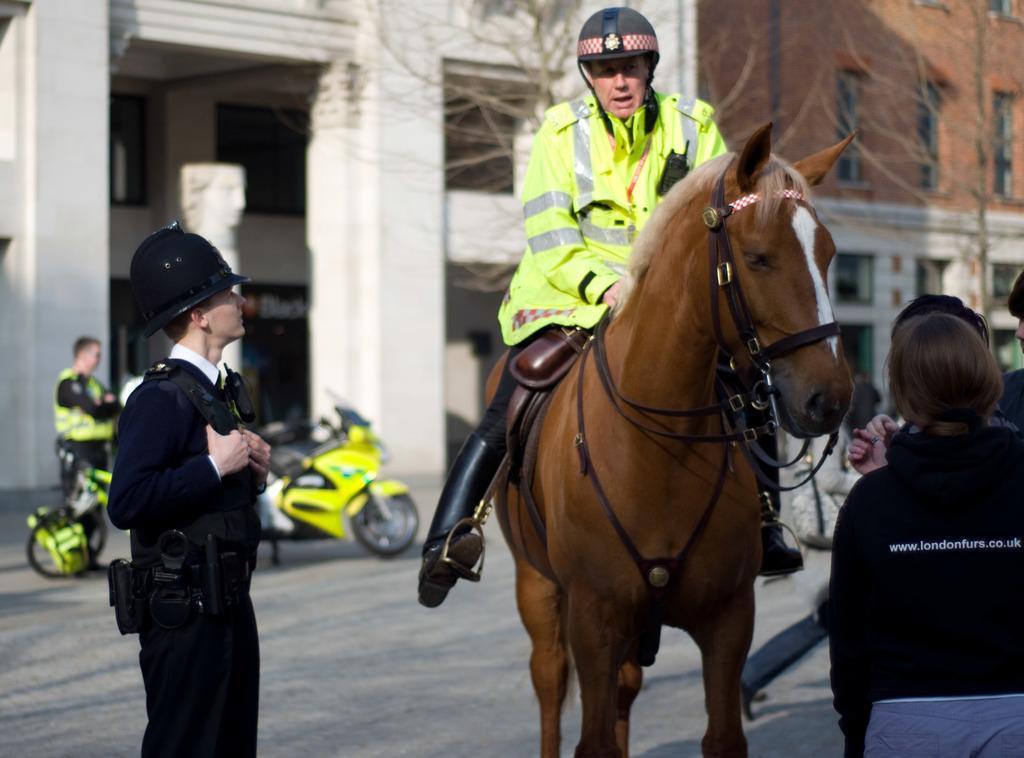How would you summarize this image in a sentence or two? In this image I can see the brown colored horse is standing on the ground and a person is sitting on the horse. I can see few persons standing on the ground, a motor bike , few trees and few buildings in the background. 